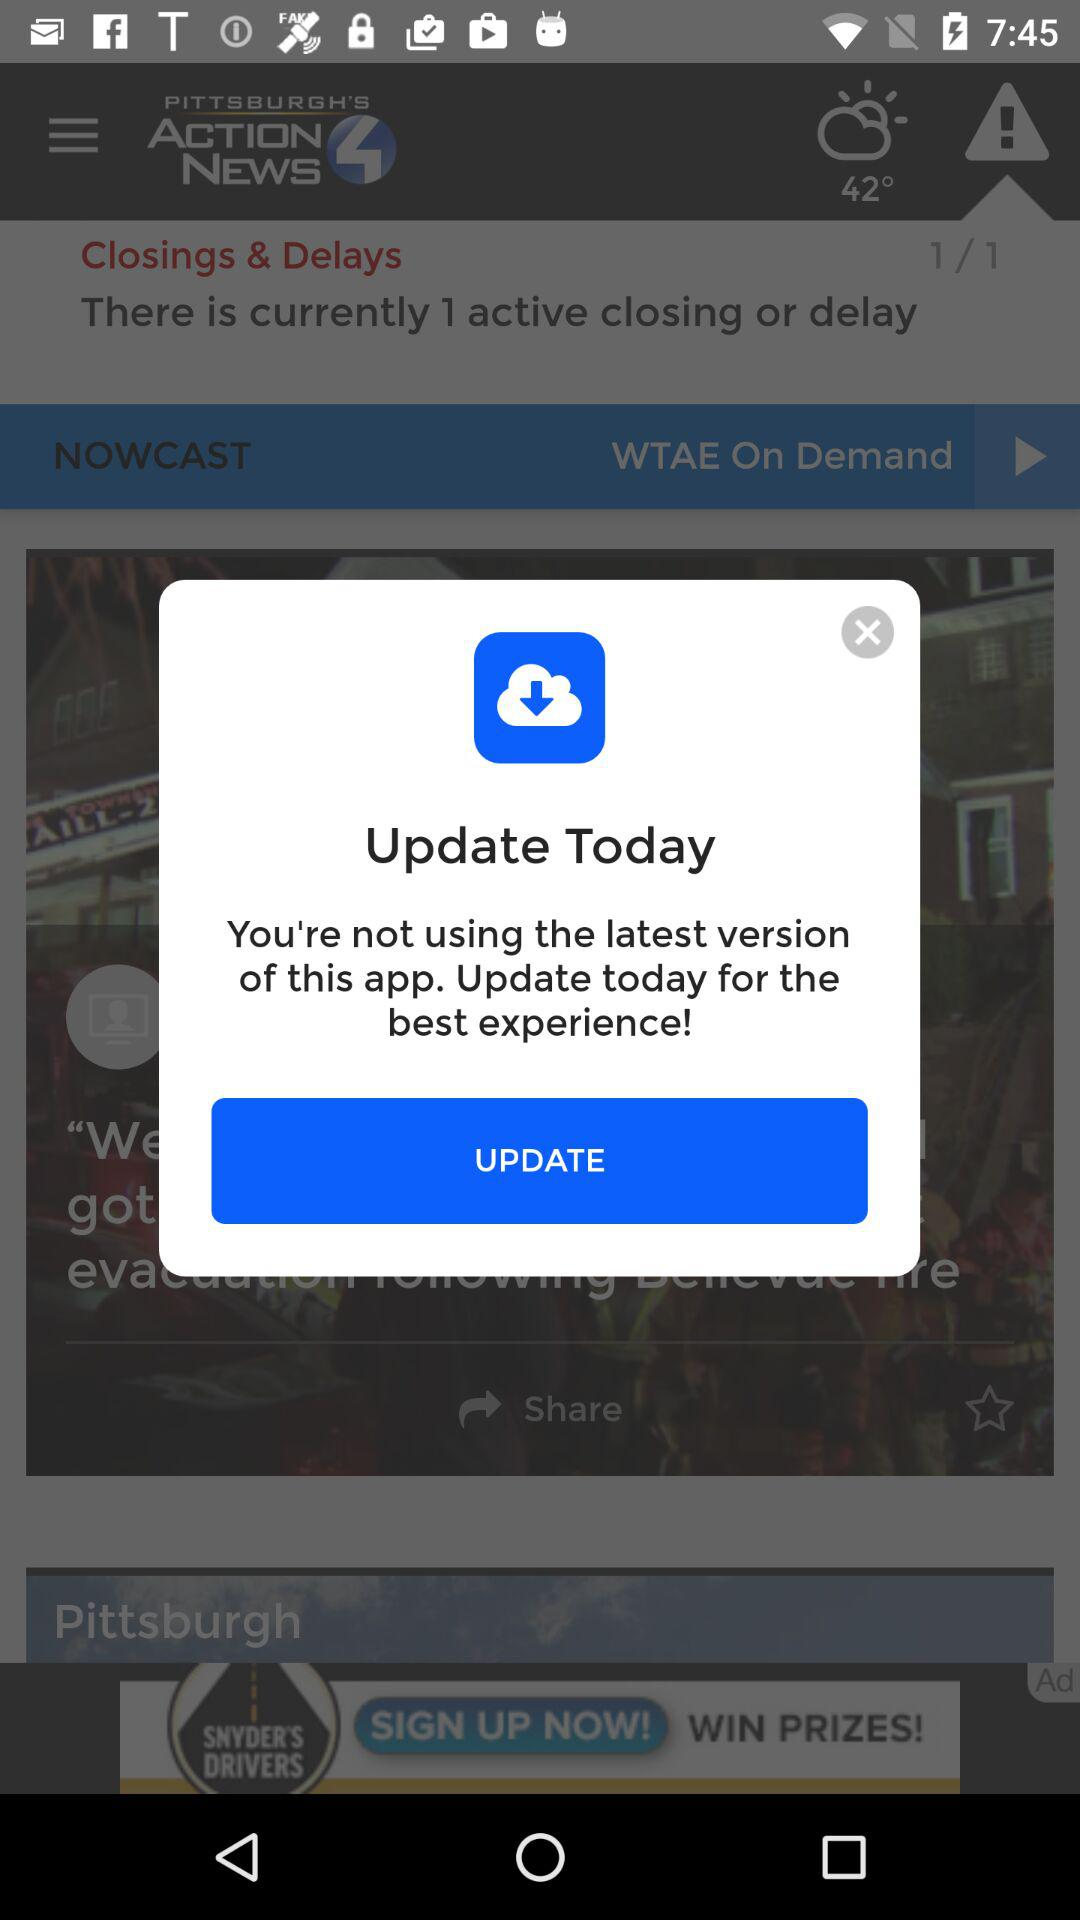When is the application asking for an update? The application is asking for an update today. 